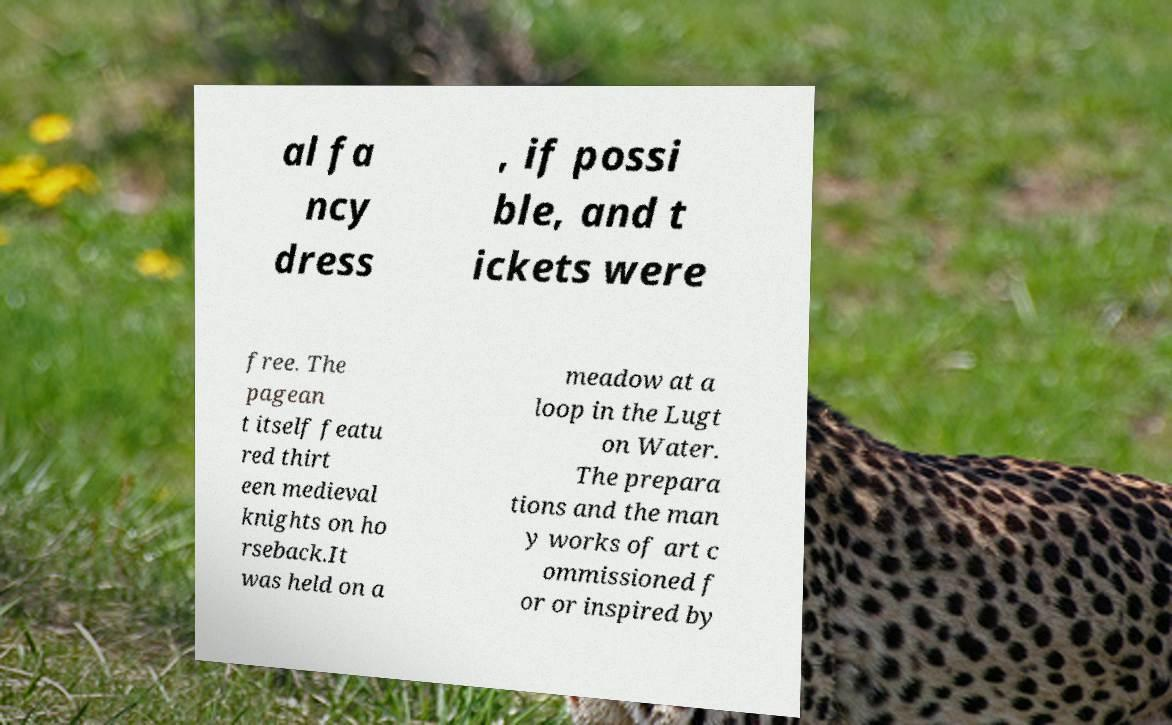Could you extract and type out the text from this image? al fa ncy dress , if possi ble, and t ickets were free. The pagean t itself featu red thirt een medieval knights on ho rseback.It was held on a meadow at a loop in the Lugt on Water. The prepara tions and the man y works of art c ommissioned f or or inspired by 